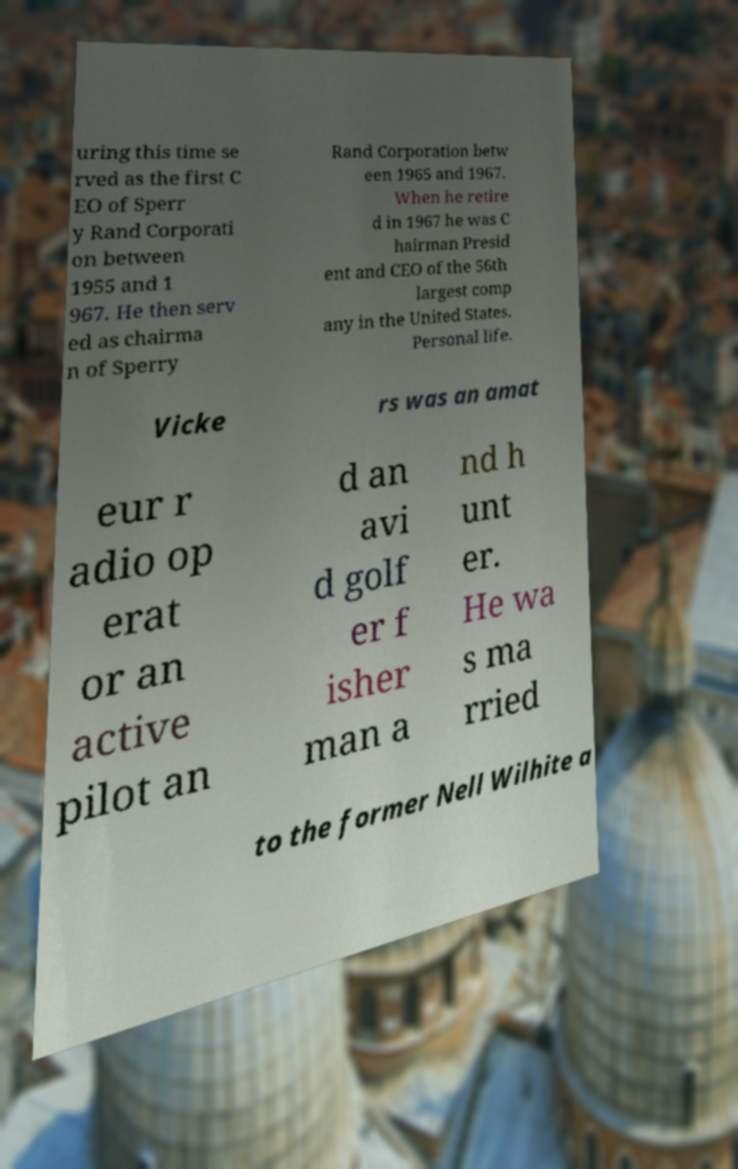Could you assist in decoding the text presented in this image and type it out clearly? uring this time se rved as the first C EO of Sperr y Rand Corporati on between 1955 and 1 967. He then serv ed as chairma n of Sperry Rand Corporation betw een 1965 and 1967. When he retire d in 1967 he was C hairman Presid ent and CEO of the 56th largest comp any in the United States. Personal life. Vicke rs was an amat eur r adio op erat or an active pilot an d an avi d golf er f isher man a nd h unt er. He wa s ma rried to the former Nell Wilhite a 